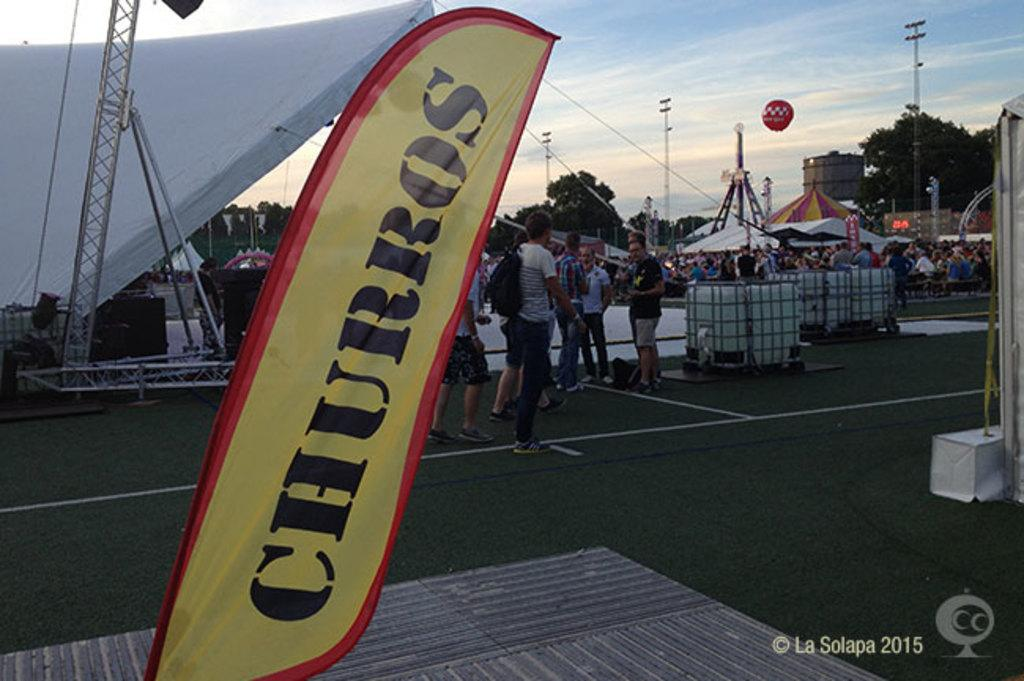<image>
Relay a brief, clear account of the picture shown. A yellow sign at a carnival is advertising churros. 